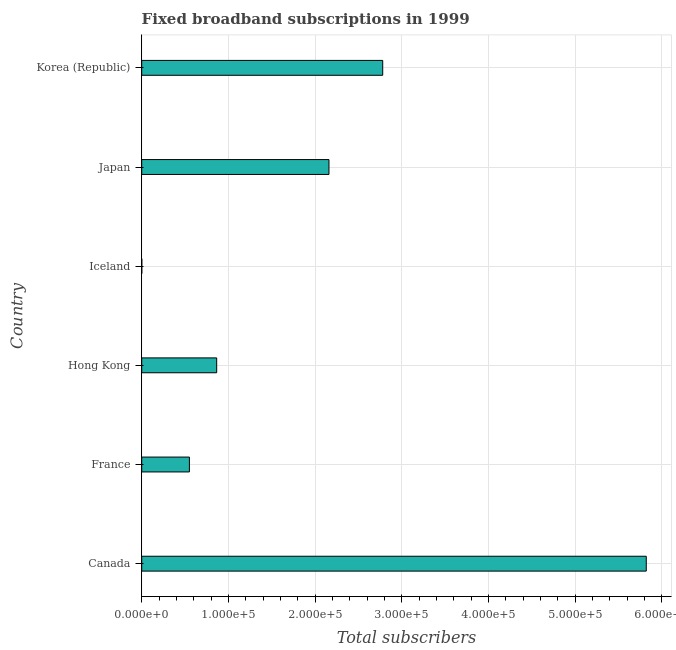Does the graph contain any zero values?
Offer a very short reply. No. Does the graph contain grids?
Give a very brief answer. Yes. What is the title of the graph?
Your response must be concise. Fixed broadband subscriptions in 1999. What is the label or title of the X-axis?
Your response must be concise. Total subscribers. What is the total number of fixed broadband subscriptions in Japan?
Your answer should be very brief. 2.16e+05. Across all countries, what is the maximum total number of fixed broadband subscriptions?
Your answer should be very brief. 5.82e+05. In which country was the total number of fixed broadband subscriptions maximum?
Make the answer very short. Canada. What is the sum of the total number of fixed broadband subscriptions?
Make the answer very short. 1.22e+06. What is the difference between the total number of fixed broadband subscriptions in Canada and France?
Your answer should be compact. 5.27e+05. What is the average total number of fixed broadband subscriptions per country?
Your answer should be very brief. 2.03e+05. What is the median total number of fixed broadband subscriptions?
Ensure brevity in your answer.  1.51e+05. In how many countries, is the total number of fixed broadband subscriptions greater than 460000 ?
Your response must be concise. 1. What is the ratio of the total number of fixed broadband subscriptions in Canada to that in Hong Kong?
Provide a short and direct response. 6.73. Is the total number of fixed broadband subscriptions in Hong Kong less than that in Japan?
Your answer should be very brief. Yes. Is the difference between the total number of fixed broadband subscriptions in Iceland and Japan greater than the difference between any two countries?
Offer a terse response. No. What is the difference between the highest and the second highest total number of fixed broadband subscriptions?
Offer a very short reply. 3.04e+05. Is the sum of the total number of fixed broadband subscriptions in Iceland and Japan greater than the maximum total number of fixed broadband subscriptions across all countries?
Your response must be concise. No. What is the difference between the highest and the lowest total number of fixed broadband subscriptions?
Provide a succinct answer. 5.82e+05. How many bars are there?
Provide a succinct answer. 6. Are all the bars in the graph horizontal?
Give a very brief answer. Yes. How many countries are there in the graph?
Offer a terse response. 6. What is the Total subscribers of Canada?
Your response must be concise. 5.82e+05. What is the Total subscribers in France?
Your answer should be compact. 5.50e+04. What is the Total subscribers of Hong Kong?
Ensure brevity in your answer.  8.65e+04. What is the Total subscribers of Japan?
Your answer should be very brief. 2.16e+05. What is the Total subscribers of Korea (Republic)?
Ensure brevity in your answer.  2.78e+05. What is the difference between the Total subscribers in Canada and France?
Provide a succinct answer. 5.27e+05. What is the difference between the Total subscribers in Canada and Hong Kong?
Offer a very short reply. 4.96e+05. What is the difference between the Total subscribers in Canada and Iceland?
Keep it short and to the point. 5.82e+05. What is the difference between the Total subscribers in Canada and Japan?
Keep it short and to the point. 3.66e+05. What is the difference between the Total subscribers in Canada and Korea (Republic)?
Offer a terse response. 3.04e+05. What is the difference between the Total subscribers in France and Hong Kong?
Your answer should be compact. -3.15e+04. What is the difference between the Total subscribers in France and Iceland?
Offer a terse response. 5.49e+04. What is the difference between the Total subscribers in France and Japan?
Provide a succinct answer. -1.61e+05. What is the difference between the Total subscribers in France and Korea (Republic)?
Keep it short and to the point. -2.23e+05. What is the difference between the Total subscribers in Hong Kong and Iceland?
Ensure brevity in your answer.  8.64e+04. What is the difference between the Total subscribers in Hong Kong and Japan?
Ensure brevity in your answer.  -1.30e+05. What is the difference between the Total subscribers in Hong Kong and Korea (Republic)?
Offer a terse response. -1.92e+05. What is the difference between the Total subscribers in Iceland and Japan?
Keep it short and to the point. -2.16e+05. What is the difference between the Total subscribers in Iceland and Korea (Republic)?
Your response must be concise. -2.78e+05. What is the difference between the Total subscribers in Japan and Korea (Republic)?
Your answer should be compact. -6.20e+04. What is the ratio of the Total subscribers in Canada to that in France?
Ensure brevity in your answer.  10.58. What is the ratio of the Total subscribers in Canada to that in Hong Kong?
Your answer should be compact. 6.73. What is the ratio of the Total subscribers in Canada to that in Iceland?
Ensure brevity in your answer.  7185.19. What is the ratio of the Total subscribers in Canada to that in Japan?
Make the answer very short. 2.69. What is the ratio of the Total subscribers in Canada to that in Korea (Republic)?
Your answer should be compact. 2.09. What is the ratio of the Total subscribers in France to that in Hong Kong?
Offer a very short reply. 0.64. What is the ratio of the Total subscribers in France to that in Iceland?
Your response must be concise. 679.01. What is the ratio of the Total subscribers in France to that in Japan?
Your answer should be very brief. 0.26. What is the ratio of the Total subscribers in France to that in Korea (Republic)?
Make the answer very short. 0.2. What is the ratio of the Total subscribers in Hong Kong to that in Iceland?
Offer a terse response. 1067.49. What is the ratio of the Total subscribers in Hong Kong to that in Japan?
Make the answer very short. 0.4. What is the ratio of the Total subscribers in Hong Kong to that in Korea (Republic)?
Provide a succinct answer. 0.31. What is the ratio of the Total subscribers in Iceland to that in Japan?
Ensure brevity in your answer.  0. What is the ratio of the Total subscribers in Iceland to that in Korea (Republic)?
Give a very brief answer. 0. What is the ratio of the Total subscribers in Japan to that in Korea (Republic)?
Provide a succinct answer. 0.78. 